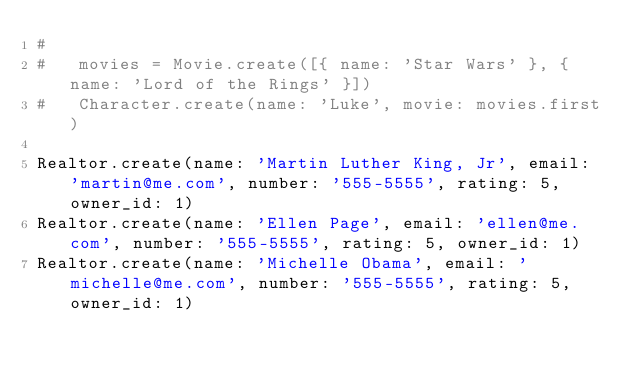<code> <loc_0><loc_0><loc_500><loc_500><_Ruby_>#
#   movies = Movie.create([{ name: 'Star Wars' }, { name: 'Lord of the Rings' }])
#   Character.create(name: 'Luke', movie: movies.first)

Realtor.create(name: 'Martin Luther King, Jr', email: 'martin@me.com', number: '555-5555', rating: 5, owner_id: 1)
Realtor.create(name: 'Ellen Page', email: 'ellen@me.com', number: '555-5555', rating: 5, owner_id: 1)
Realtor.create(name: 'Michelle Obama', email: 'michelle@me.com', number: '555-5555', rating: 5, owner_id: 1)
</code> 